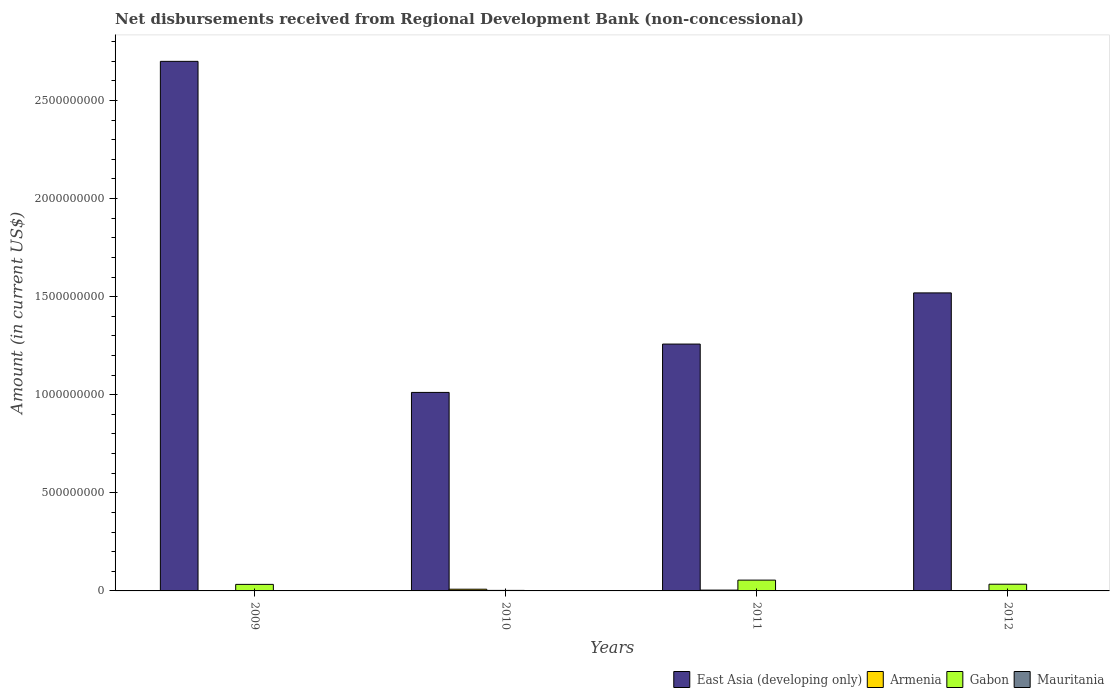How many groups of bars are there?
Make the answer very short. 4. How many bars are there on the 1st tick from the right?
Keep it short and to the point. 3. What is the label of the 3rd group of bars from the left?
Offer a terse response. 2011. What is the amount of disbursements received from Regional Development Bank in Armenia in 2011?
Give a very brief answer. 4.21e+06. Across all years, what is the maximum amount of disbursements received from Regional Development Bank in East Asia (developing only)?
Your response must be concise. 2.70e+09. Across all years, what is the minimum amount of disbursements received from Regional Development Bank in Armenia?
Offer a very short reply. 1.28e+06. What is the total amount of disbursements received from Regional Development Bank in East Asia (developing only) in the graph?
Make the answer very short. 6.49e+09. What is the difference between the amount of disbursements received from Regional Development Bank in Gabon in 2009 and that in 2012?
Ensure brevity in your answer.  -9.03e+05. What is the difference between the amount of disbursements received from Regional Development Bank in Armenia in 2010 and the amount of disbursements received from Regional Development Bank in East Asia (developing only) in 2009?
Your response must be concise. -2.69e+09. What is the average amount of disbursements received from Regional Development Bank in East Asia (developing only) per year?
Your answer should be very brief. 1.62e+09. In the year 2011, what is the difference between the amount of disbursements received from Regional Development Bank in Armenia and amount of disbursements received from Regional Development Bank in East Asia (developing only)?
Ensure brevity in your answer.  -1.25e+09. In how many years, is the amount of disbursements received from Regional Development Bank in Armenia greater than 2000000000 US$?
Your response must be concise. 0. What is the ratio of the amount of disbursements received from Regional Development Bank in Armenia in 2010 to that in 2012?
Offer a very short reply. 4.94. Is the amount of disbursements received from Regional Development Bank in Gabon in 2011 less than that in 2012?
Make the answer very short. No. What is the difference between the highest and the second highest amount of disbursements received from Regional Development Bank in Gabon?
Offer a very short reply. 2.09e+07. What is the difference between the highest and the lowest amount of disbursements received from Regional Development Bank in Armenia?
Make the answer very short. 7.47e+06. Is it the case that in every year, the sum of the amount of disbursements received from Regional Development Bank in Armenia and amount of disbursements received from Regional Development Bank in East Asia (developing only) is greater than the amount of disbursements received from Regional Development Bank in Gabon?
Offer a very short reply. Yes. How many bars are there?
Make the answer very short. 12. How many years are there in the graph?
Keep it short and to the point. 4. Does the graph contain grids?
Offer a very short reply. No. Where does the legend appear in the graph?
Provide a short and direct response. Bottom right. How many legend labels are there?
Give a very brief answer. 4. How are the legend labels stacked?
Offer a very short reply. Horizontal. What is the title of the graph?
Your response must be concise. Net disbursements received from Regional Development Bank (non-concessional). Does "Palau" appear as one of the legend labels in the graph?
Provide a succinct answer. No. What is the label or title of the X-axis?
Make the answer very short. Years. What is the Amount (in current US$) of East Asia (developing only) in 2009?
Your answer should be very brief. 2.70e+09. What is the Amount (in current US$) of Armenia in 2009?
Your answer should be compact. 1.28e+06. What is the Amount (in current US$) of Gabon in 2009?
Give a very brief answer. 3.33e+07. What is the Amount (in current US$) of Mauritania in 2009?
Give a very brief answer. 0. What is the Amount (in current US$) in East Asia (developing only) in 2010?
Your response must be concise. 1.01e+09. What is the Amount (in current US$) in Armenia in 2010?
Make the answer very short. 8.75e+06. What is the Amount (in current US$) of Gabon in 2010?
Your answer should be compact. 2.64e+06. What is the Amount (in current US$) in Mauritania in 2010?
Provide a succinct answer. 0. What is the Amount (in current US$) in East Asia (developing only) in 2011?
Offer a very short reply. 1.26e+09. What is the Amount (in current US$) of Armenia in 2011?
Provide a short and direct response. 4.21e+06. What is the Amount (in current US$) in Gabon in 2011?
Keep it short and to the point. 5.51e+07. What is the Amount (in current US$) of Mauritania in 2011?
Offer a terse response. 0. What is the Amount (in current US$) in East Asia (developing only) in 2012?
Make the answer very short. 1.52e+09. What is the Amount (in current US$) of Armenia in 2012?
Make the answer very short. 1.77e+06. What is the Amount (in current US$) of Gabon in 2012?
Offer a very short reply. 3.42e+07. What is the Amount (in current US$) in Mauritania in 2012?
Provide a succinct answer. 0. Across all years, what is the maximum Amount (in current US$) in East Asia (developing only)?
Keep it short and to the point. 2.70e+09. Across all years, what is the maximum Amount (in current US$) of Armenia?
Give a very brief answer. 8.75e+06. Across all years, what is the maximum Amount (in current US$) of Gabon?
Your answer should be very brief. 5.51e+07. Across all years, what is the minimum Amount (in current US$) in East Asia (developing only)?
Your answer should be very brief. 1.01e+09. Across all years, what is the minimum Amount (in current US$) in Armenia?
Ensure brevity in your answer.  1.28e+06. Across all years, what is the minimum Amount (in current US$) of Gabon?
Provide a short and direct response. 2.64e+06. What is the total Amount (in current US$) in East Asia (developing only) in the graph?
Provide a succinct answer. 6.49e+09. What is the total Amount (in current US$) of Armenia in the graph?
Offer a terse response. 1.60e+07. What is the total Amount (in current US$) in Gabon in the graph?
Provide a succinct answer. 1.25e+08. What is the total Amount (in current US$) of Mauritania in the graph?
Your answer should be very brief. 0. What is the difference between the Amount (in current US$) in East Asia (developing only) in 2009 and that in 2010?
Keep it short and to the point. 1.69e+09. What is the difference between the Amount (in current US$) of Armenia in 2009 and that in 2010?
Your response must be concise. -7.47e+06. What is the difference between the Amount (in current US$) in Gabon in 2009 and that in 2010?
Provide a short and direct response. 3.07e+07. What is the difference between the Amount (in current US$) in East Asia (developing only) in 2009 and that in 2011?
Offer a very short reply. 1.44e+09. What is the difference between the Amount (in current US$) in Armenia in 2009 and that in 2011?
Provide a short and direct response. -2.93e+06. What is the difference between the Amount (in current US$) of Gabon in 2009 and that in 2011?
Keep it short and to the point. -2.18e+07. What is the difference between the Amount (in current US$) of East Asia (developing only) in 2009 and that in 2012?
Ensure brevity in your answer.  1.18e+09. What is the difference between the Amount (in current US$) of Armenia in 2009 and that in 2012?
Give a very brief answer. -4.95e+05. What is the difference between the Amount (in current US$) of Gabon in 2009 and that in 2012?
Give a very brief answer. -9.03e+05. What is the difference between the Amount (in current US$) in East Asia (developing only) in 2010 and that in 2011?
Provide a succinct answer. -2.46e+08. What is the difference between the Amount (in current US$) in Armenia in 2010 and that in 2011?
Your answer should be very brief. 4.54e+06. What is the difference between the Amount (in current US$) of Gabon in 2010 and that in 2011?
Provide a succinct answer. -5.24e+07. What is the difference between the Amount (in current US$) in East Asia (developing only) in 2010 and that in 2012?
Provide a succinct answer. -5.07e+08. What is the difference between the Amount (in current US$) in Armenia in 2010 and that in 2012?
Offer a very short reply. 6.98e+06. What is the difference between the Amount (in current US$) in Gabon in 2010 and that in 2012?
Provide a succinct answer. -3.16e+07. What is the difference between the Amount (in current US$) of East Asia (developing only) in 2011 and that in 2012?
Give a very brief answer. -2.61e+08. What is the difference between the Amount (in current US$) in Armenia in 2011 and that in 2012?
Offer a very short reply. 2.44e+06. What is the difference between the Amount (in current US$) in Gabon in 2011 and that in 2012?
Offer a very short reply. 2.09e+07. What is the difference between the Amount (in current US$) of East Asia (developing only) in 2009 and the Amount (in current US$) of Armenia in 2010?
Offer a very short reply. 2.69e+09. What is the difference between the Amount (in current US$) of East Asia (developing only) in 2009 and the Amount (in current US$) of Gabon in 2010?
Keep it short and to the point. 2.70e+09. What is the difference between the Amount (in current US$) in Armenia in 2009 and the Amount (in current US$) in Gabon in 2010?
Ensure brevity in your answer.  -1.36e+06. What is the difference between the Amount (in current US$) of East Asia (developing only) in 2009 and the Amount (in current US$) of Armenia in 2011?
Provide a short and direct response. 2.70e+09. What is the difference between the Amount (in current US$) of East Asia (developing only) in 2009 and the Amount (in current US$) of Gabon in 2011?
Your response must be concise. 2.64e+09. What is the difference between the Amount (in current US$) of Armenia in 2009 and the Amount (in current US$) of Gabon in 2011?
Your answer should be compact. -5.38e+07. What is the difference between the Amount (in current US$) of East Asia (developing only) in 2009 and the Amount (in current US$) of Armenia in 2012?
Give a very brief answer. 2.70e+09. What is the difference between the Amount (in current US$) in East Asia (developing only) in 2009 and the Amount (in current US$) in Gabon in 2012?
Ensure brevity in your answer.  2.67e+09. What is the difference between the Amount (in current US$) in Armenia in 2009 and the Amount (in current US$) in Gabon in 2012?
Make the answer very short. -3.29e+07. What is the difference between the Amount (in current US$) in East Asia (developing only) in 2010 and the Amount (in current US$) in Armenia in 2011?
Offer a very short reply. 1.01e+09. What is the difference between the Amount (in current US$) in East Asia (developing only) in 2010 and the Amount (in current US$) in Gabon in 2011?
Your response must be concise. 9.57e+08. What is the difference between the Amount (in current US$) of Armenia in 2010 and the Amount (in current US$) of Gabon in 2011?
Your answer should be very brief. -4.63e+07. What is the difference between the Amount (in current US$) in East Asia (developing only) in 2010 and the Amount (in current US$) in Armenia in 2012?
Your answer should be very brief. 1.01e+09. What is the difference between the Amount (in current US$) in East Asia (developing only) in 2010 and the Amount (in current US$) in Gabon in 2012?
Ensure brevity in your answer.  9.78e+08. What is the difference between the Amount (in current US$) of Armenia in 2010 and the Amount (in current US$) of Gabon in 2012?
Keep it short and to the point. -2.55e+07. What is the difference between the Amount (in current US$) of East Asia (developing only) in 2011 and the Amount (in current US$) of Armenia in 2012?
Offer a terse response. 1.26e+09. What is the difference between the Amount (in current US$) of East Asia (developing only) in 2011 and the Amount (in current US$) of Gabon in 2012?
Offer a very short reply. 1.22e+09. What is the difference between the Amount (in current US$) of Armenia in 2011 and the Amount (in current US$) of Gabon in 2012?
Keep it short and to the point. -3.00e+07. What is the average Amount (in current US$) of East Asia (developing only) per year?
Your answer should be compact. 1.62e+09. What is the average Amount (in current US$) in Armenia per year?
Your answer should be compact. 4.00e+06. What is the average Amount (in current US$) in Gabon per year?
Your response must be concise. 3.13e+07. What is the average Amount (in current US$) in Mauritania per year?
Offer a terse response. 0. In the year 2009, what is the difference between the Amount (in current US$) of East Asia (developing only) and Amount (in current US$) of Armenia?
Your answer should be compact. 2.70e+09. In the year 2009, what is the difference between the Amount (in current US$) in East Asia (developing only) and Amount (in current US$) in Gabon?
Provide a short and direct response. 2.67e+09. In the year 2009, what is the difference between the Amount (in current US$) in Armenia and Amount (in current US$) in Gabon?
Your answer should be compact. -3.20e+07. In the year 2010, what is the difference between the Amount (in current US$) of East Asia (developing only) and Amount (in current US$) of Armenia?
Make the answer very short. 1.00e+09. In the year 2010, what is the difference between the Amount (in current US$) of East Asia (developing only) and Amount (in current US$) of Gabon?
Your response must be concise. 1.01e+09. In the year 2010, what is the difference between the Amount (in current US$) of Armenia and Amount (in current US$) of Gabon?
Ensure brevity in your answer.  6.11e+06. In the year 2011, what is the difference between the Amount (in current US$) of East Asia (developing only) and Amount (in current US$) of Armenia?
Make the answer very short. 1.25e+09. In the year 2011, what is the difference between the Amount (in current US$) of East Asia (developing only) and Amount (in current US$) of Gabon?
Your answer should be very brief. 1.20e+09. In the year 2011, what is the difference between the Amount (in current US$) in Armenia and Amount (in current US$) in Gabon?
Provide a short and direct response. -5.09e+07. In the year 2012, what is the difference between the Amount (in current US$) in East Asia (developing only) and Amount (in current US$) in Armenia?
Keep it short and to the point. 1.52e+09. In the year 2012, what is the difference between the Amount (in current US$) of East Asia (developing only) and Amount (in current US$) of Gabon?
Keep it short and to the point. 1.49e+09. In the year 2012, what is the difference between the Amount (in current US$) in Armenia and Amount (in current US$) in Gabon?
Offer a terse response. -3.24e+07. What is the ratio of the Amount (in current US$) in East Asia (developing only) in 2009 to that in 2010?
Offer a terse response. 2.67. What is the ratio of the Amount (in current US$) of Armenia in 2009 to that in 2010?
Give a very brief answer. 0.15. What is the ratio of the Amount (in current US$) of Gabon in 2009 to that in 2010?
Your answer should be compact. 12.62. What is the ratio of the Amount (in current US$) of East Asia (developing only) in 2009 to that in 2011?
Your response must be concise. 2.15. What is the ratio of the Amount (in current US$) in Armenia in 2009 to that in 2011?
Keep it short and to the point. 0.3. What is the ratio of the Amount (in current US$) in Gabon in 2009 to that in 2011?
Your answer should be compact. 0.6. What is the ratio of the Amount (in current US$) in East Asia (developing only) in 2009 to that in 2012?
Your response must be concise. 1.78. What is the ratio of the Amount (in current US$) of Armenia in 2009 to that in 2012?
Your response must be concise. 0.72. What is the ratio of the Amount (in current US$) in Gabon in 2009 to that in 2012?
Your answer should be very brief. 0.97. What is the ratio of the Amount (in current US$) in East Asia (developing only) in 2010 to that in 2011?
Your answer should be compact. 0.8. What is the ratio of the Amount (in current US$) of Armenia in 2010 to that in 2011?
Offer a terse response. 2.08. What is the ratio of the Amount (in current US$) in Gabon in 2010 to that in 2011?
Provide a short and direct response. 0.05. What is the ratio of the Amount (in current US$) of East Asia (developing only) in 2010 to that in 2012?
Your response must be concise. 0.67. What is the ratio of the Amount (in current US$) in Armenia in 2010 to that in 2012?
Offer a very short reply. 4.94. What is the ratio of the Amount (in current US$) in Gabon in 2010 to that in 2012?
Your response must be concise. 0.08. What is the ratio of the Amount (in current US$) of East Asia (developing only) in 2011 to that in 2012?
Offer a terse response. 0.83. What is the ratio of the Amount (in current US$) of Armenia in 2011 to that in 2012?
Offer a very short reply. 2.38. What is the ratio of the Amount (in current US$) of Gabon in 2011 to that in 2012?
Provide a short and direct response. 1.61. What is the difference between the highest and the second highest Amount (in current US$) of East Asia (developing only)?
Give a very brief answer. 1.18e+09. What is the difference between the highest and the second highest Amount (in current US$) in Armenia?
Offer a very short reply. 4.54e+06. What is the difference between the highest and the second highest Amount (in current US$) of Gabon?
Provide a short and direct response. 2.09e+07. What is the difference between the highest and the lowest Amount (in current US$) of East Asia (developing only)?
Give a very brief answer. 1.69e+09. What is the difference between the highest and the lowest Amount (in current US$) in Armenia?
Keep it short and to the point. 7.47e+06. What is the difference between the highest and the lowest Amount (in current US$) in Gabon?
Provide a short and direct response. 5.24e+07. 